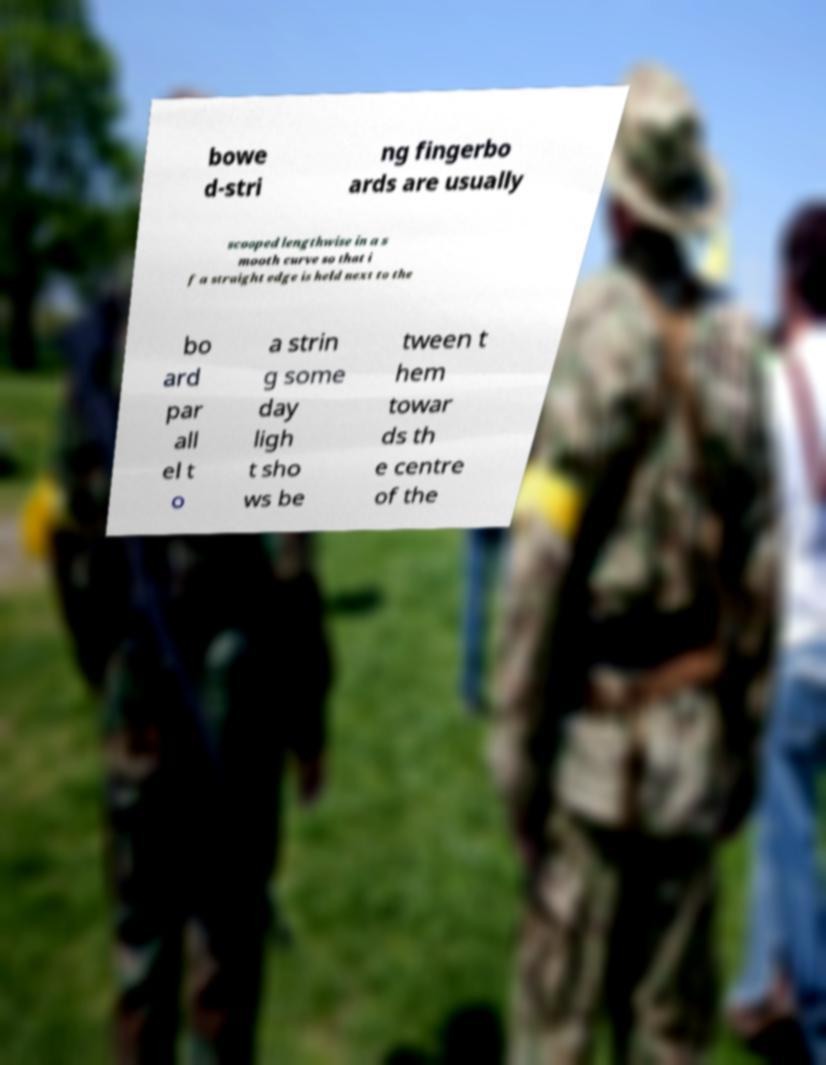Please read and relay the text visible in this image. What does it say? bowe d-stri ng fingerbo ards are usually scooped lengthwise in a s mooth curve so that i f a straight edge is held next to the bo ard par all el t o a strin g some day ligh t sho ws be tween t hem towar ds th e centre of the 